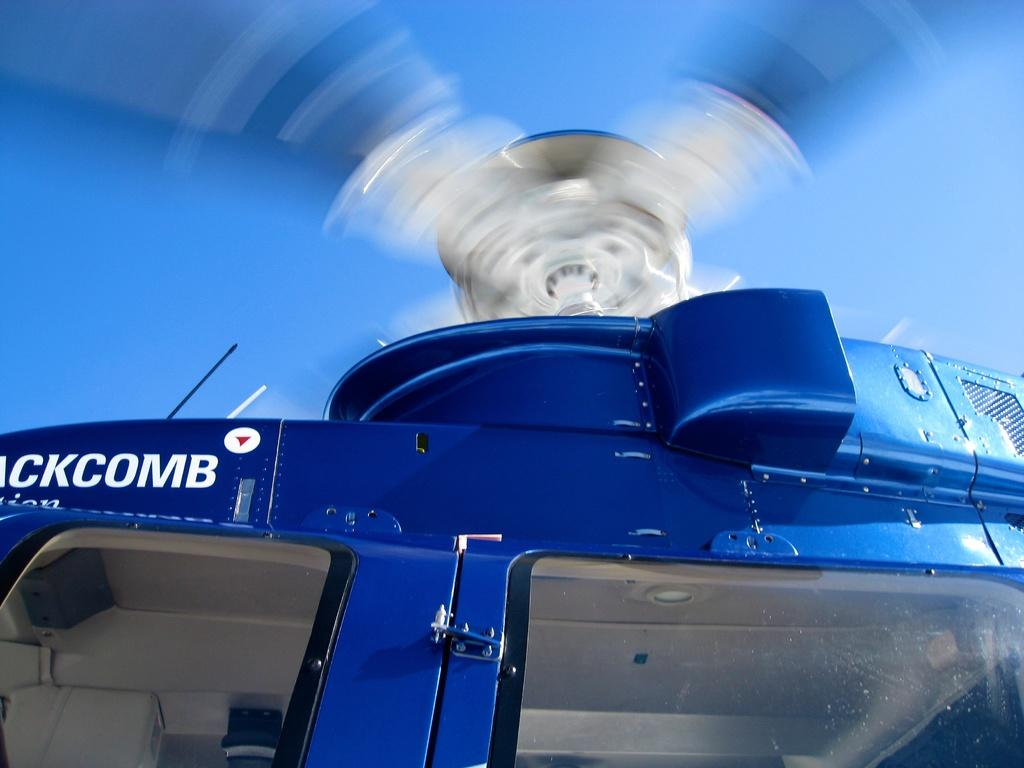What is the main subject of the image? The main subject of the image is a helicopter. How close is the view of the helicopter in the image? The image is a zoomed in picture of the helicopter. What can be seen in the background of the image? The sky is visible in the image. How many bikes are parked next to the helicopter in the image? There are no bikes present in the image; it only features a helicopter and the sky. What type of stem can be seen growing from the helicopter in the image? There is no stem growing from the helicopter in the image; it is a mechanical object. 